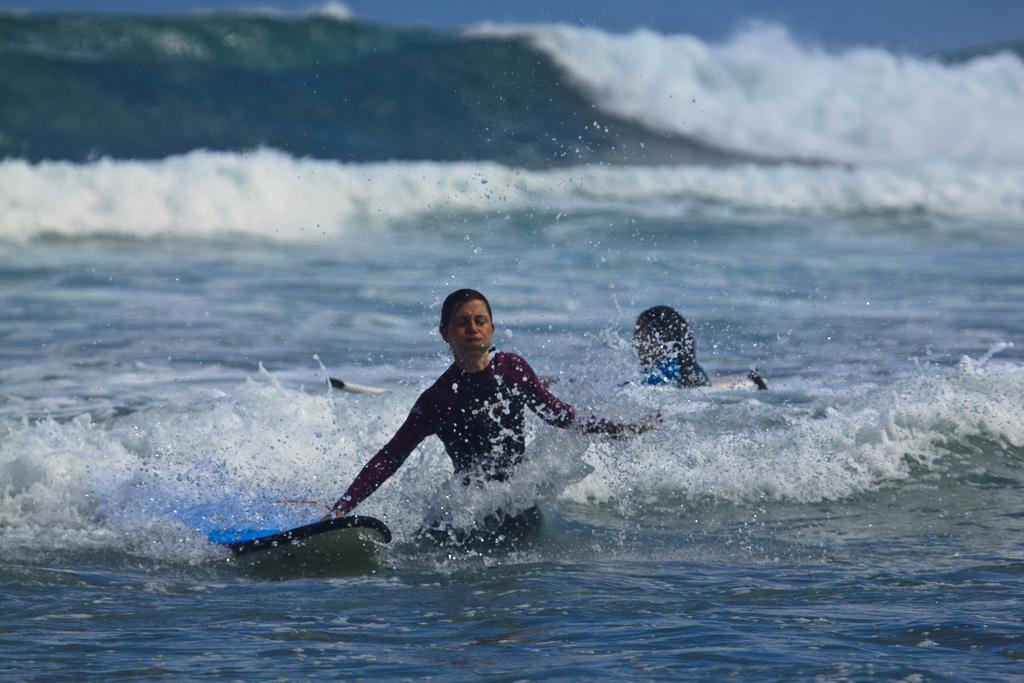Could you give a brief overview of what you see in this image? In this image we can see persons and surf boats in the water. Also there are water waves. 